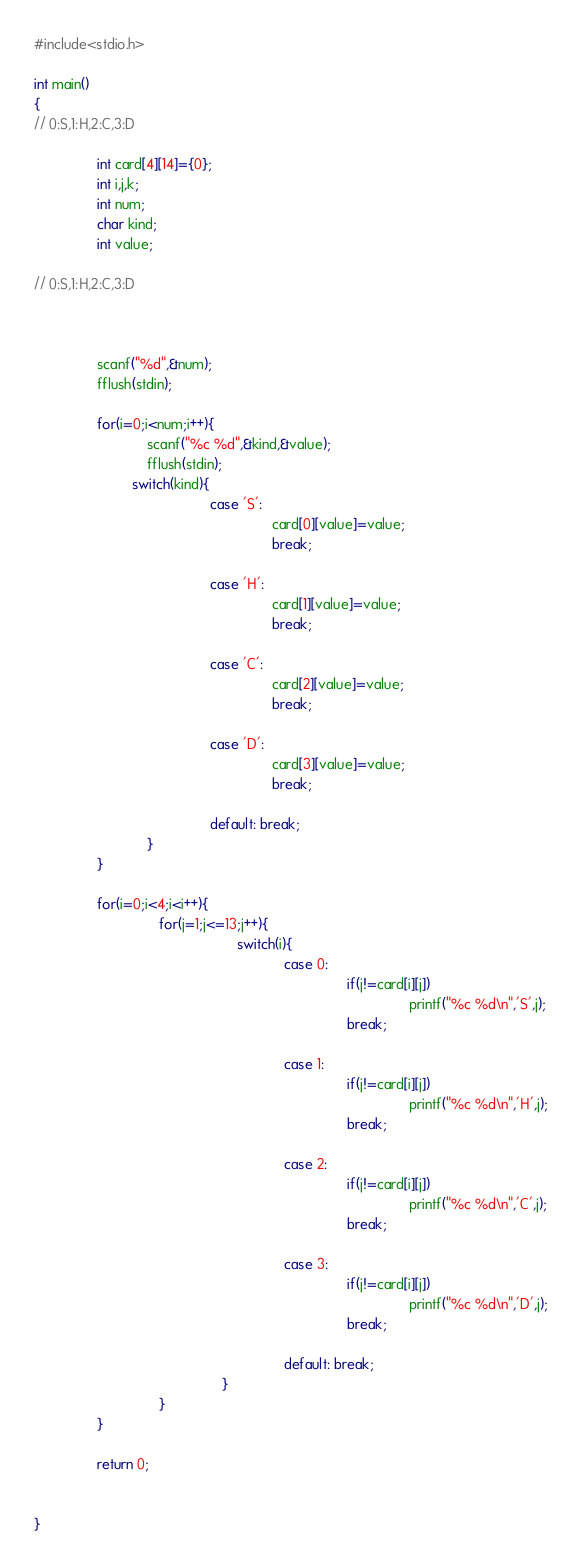Convert code to text. <code><loc_0><loc_0><loc_500><loc_500><_C_>#include<stdio.h>

int main()
{
// 0:S,1:H,2:C,3:D

				int card[4][14]={0};
				int i,j,k;
				int num;
				char kind;
				int value;

// 0:S,1:H,2:C,3:D



				scanf("%d",&num);
				fflush(stdin);

				for(i=0;i<num;i++){
							 scanf("%c %d",&kind,&value);
			 				 fflush(stdin);
						 switch(kind){
											 case 'S':
															 card[0][value]=value;
															 break;

											 case 'H':
															 card[1][value]=value;
															 break;
	
											 case 'C':
															 card[2][value]=value;
															 break;
	
											 case 'D':
															 card[3][value]=value;
															 break;

											 default: break;
							 }
				}

				for(i=0;i<4;i<i++){
								for(j=1;j<=13;j++){
													switch(i){
																case 0:
																				if(j!=card[i][j])
																								printf("%c %d\n",'S',j);
																				break;

																case 1:
																				if(j!=card[i][j])
																								printf("%c %d\n",'H',j);
																				break;

																case 2:
																				if(j!=card[i][j])
																								printf("%c %d\n",'C',j);
																				break;

																case 3:
																				if(j!=card[i][j])
																								printf("%c %d\n",'D',j);
																				break;

																default: break;
												}											
								}
				}

				return 0;


}
</code> 